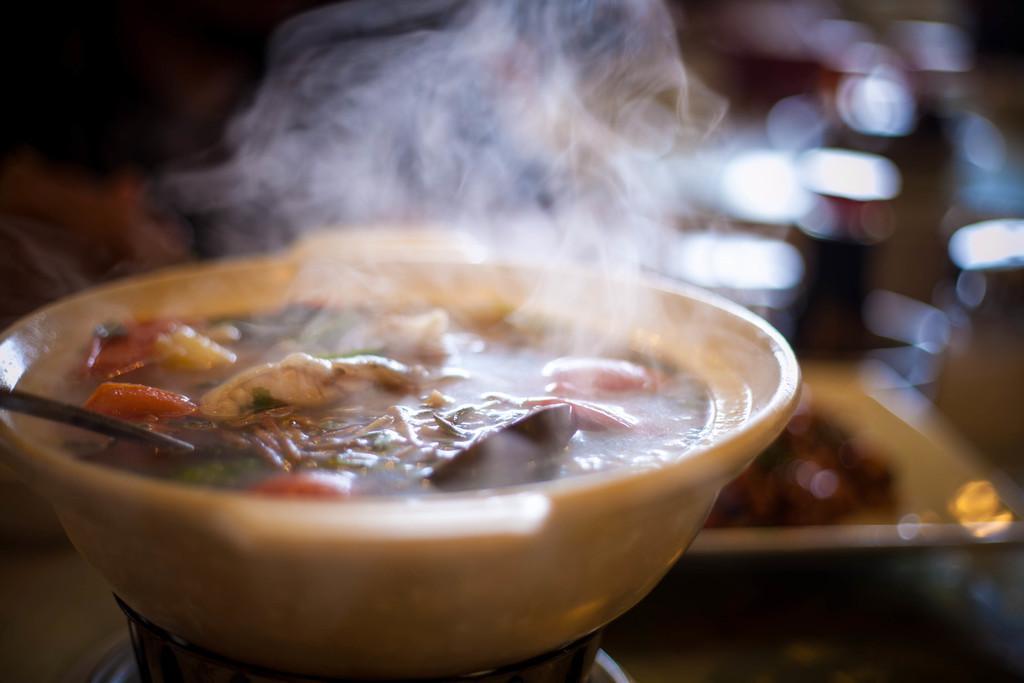How would you summarize this image in a sentence or two? In this image in the front there is food in the bowl and there is a spoon and the background is blurry. 